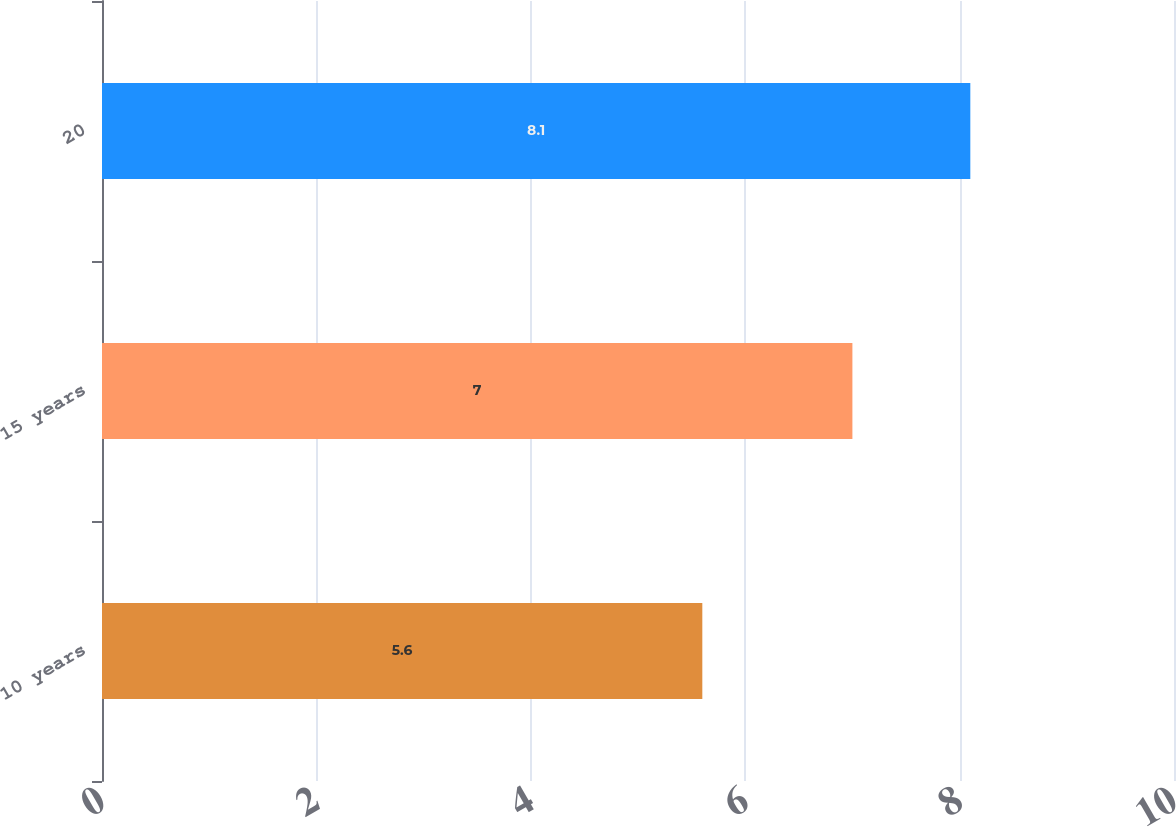<chart> <loc_0><loc_0><loc_500><loc_500><bar_chart><fcel>10 years<fcel>15 years<fcel>20<nl><fcel>5.6<fcel>7<fcel>8.1<nl></chart> 